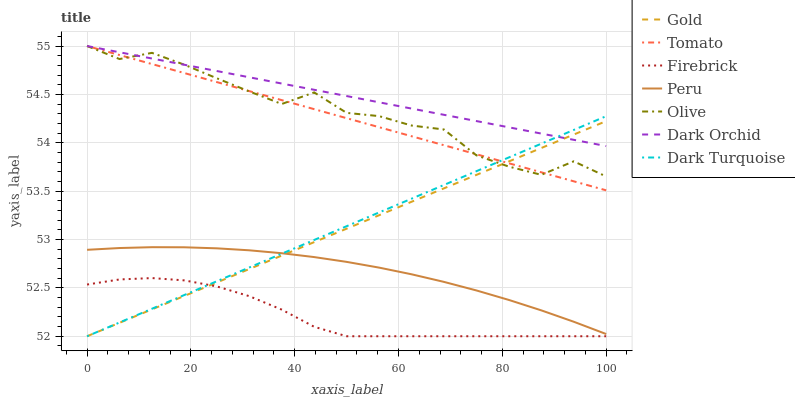Does Firebrick have the minimum area under the curve?
Answer yes or no. Yes. Does Dark Orchid have the maximum area under the curve?
Answer yes or no. Yes. Does Gold have the minimum area under the curve?
Answer yes or no. No. Does Gold have the maximum area under the curve?
Answer yes or no. No. Is Tomato the smoothest?
Answer yes or no. Yes. Is Olive the roughest?
Answer yes or no. Yes. Is Gold the smoothest?
Answer yes or no. No. Is Gold the roughest?
Answer yes or no. No. Does Dark Orchid have the lowest value?
Answer yes or no. No. Does Olive have the highest value?
Answer yes or no. Yes. Does Gold have the highest value?
Answer yes or no. No. Is Peru less than Dark Orchid?
Answer yes or no. Yes. Is Tomato greater than Firebrick?
Answer yes or no. Yes. Does Tomato intersect Olive?
Answer yes or no. Yes. Is Tomato less than Olive?
Answer yes or no. No. Is Tomato greater than Olive?
Answer yes or no. No. Does Peru intersect Dark Orchid?
Answer yes or no. No. 